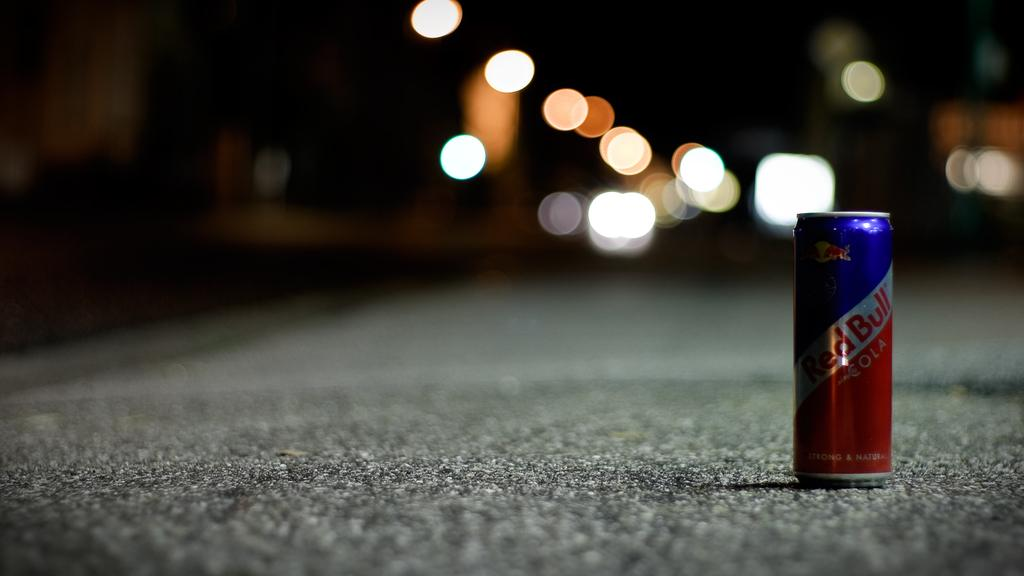<image>
Write a terse but informative summary of the picture. A can of Red Bull sitting on the concrete in the middle of a street at night. 